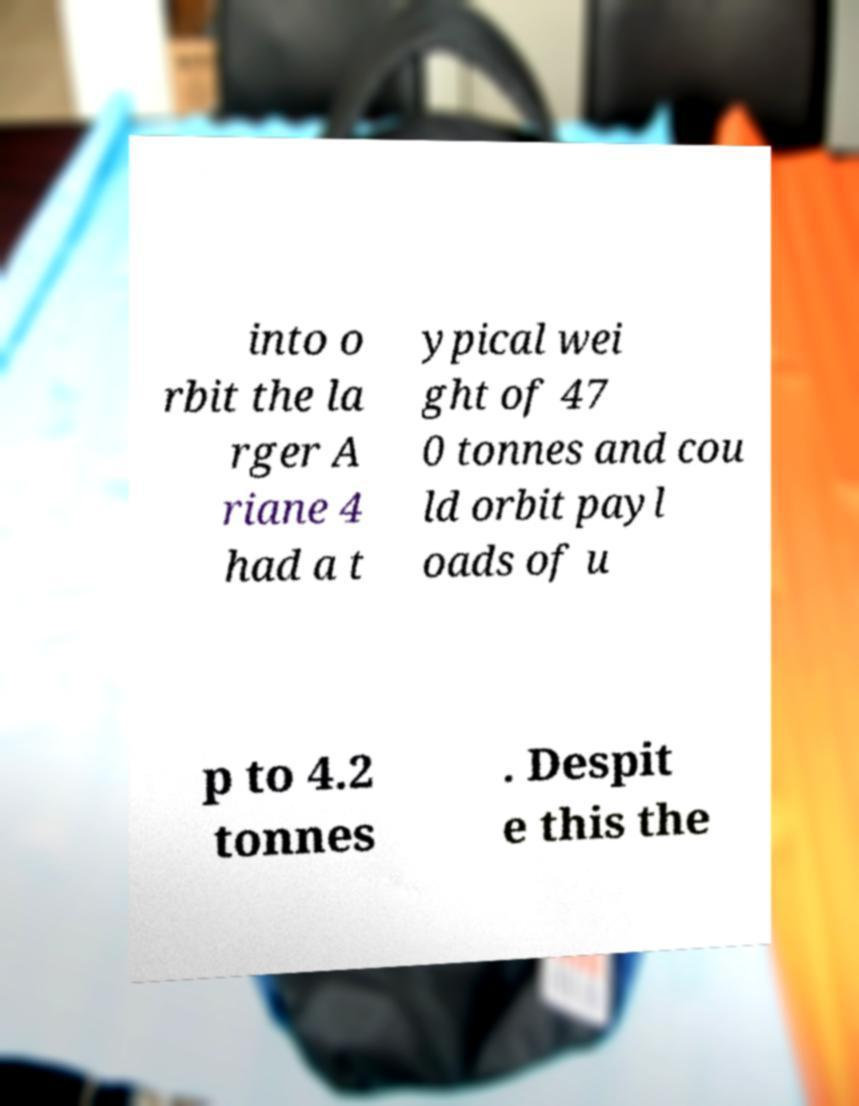Please read and relay the text visible in this image. What does it say? into o rbit the la rger A riane 4 had a t ypical wei ght of 47 0 tonnes and cou ld orbit payl oads of u p to 4.2 tonnes . Despit e this the 